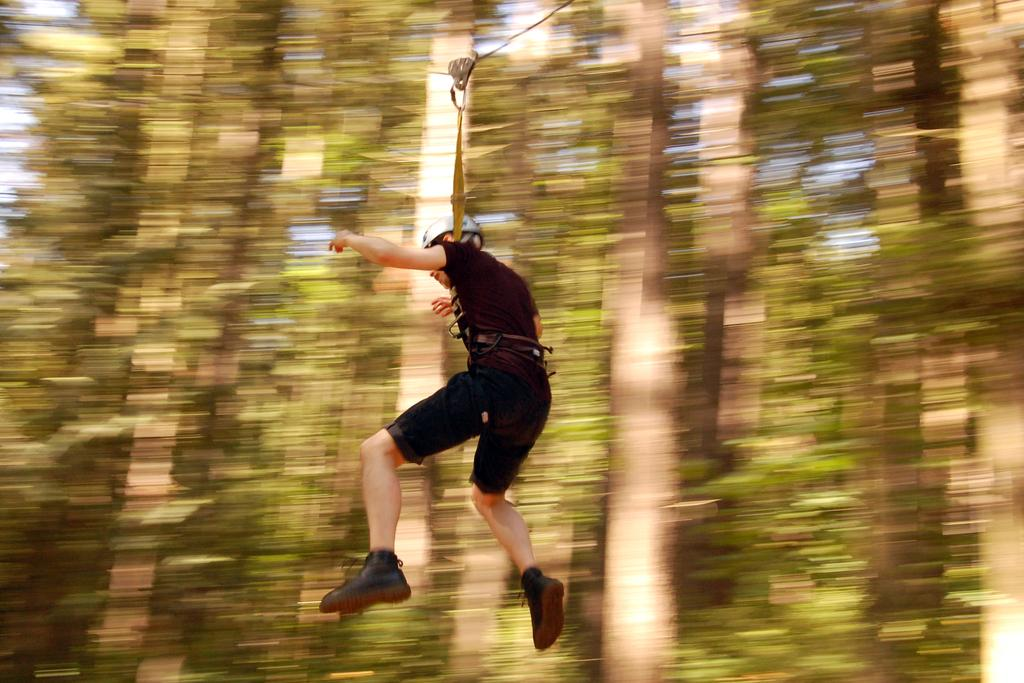What is the main subject of the image? There is a person in the image. What is the person wearing? The person is wearing a black dress and a helmet. How is the person positioned in the image? The person is hanging from a rope with a belt. What can be seen in the background of the image? The background of the image is blurry, but trees and the sky are visible. What type of rock is the person using to crack open the jar in the image? There is no rock or jar present in the image; the person is hanging from a rope with a belt. What punishment is the person receiving for their actions in the image? There is no indication of punishment in the image; the person is simply hanging from a rope with a belt. 